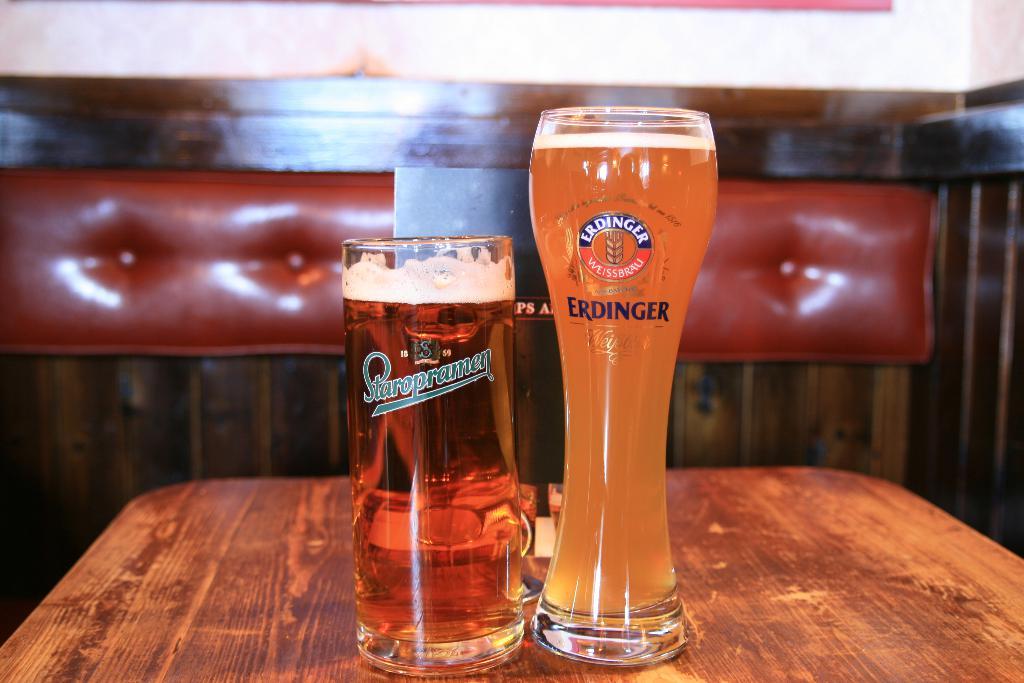What type of beer is inside of the erdinger glass?
Provide a succinct answer. Weissbrau. 